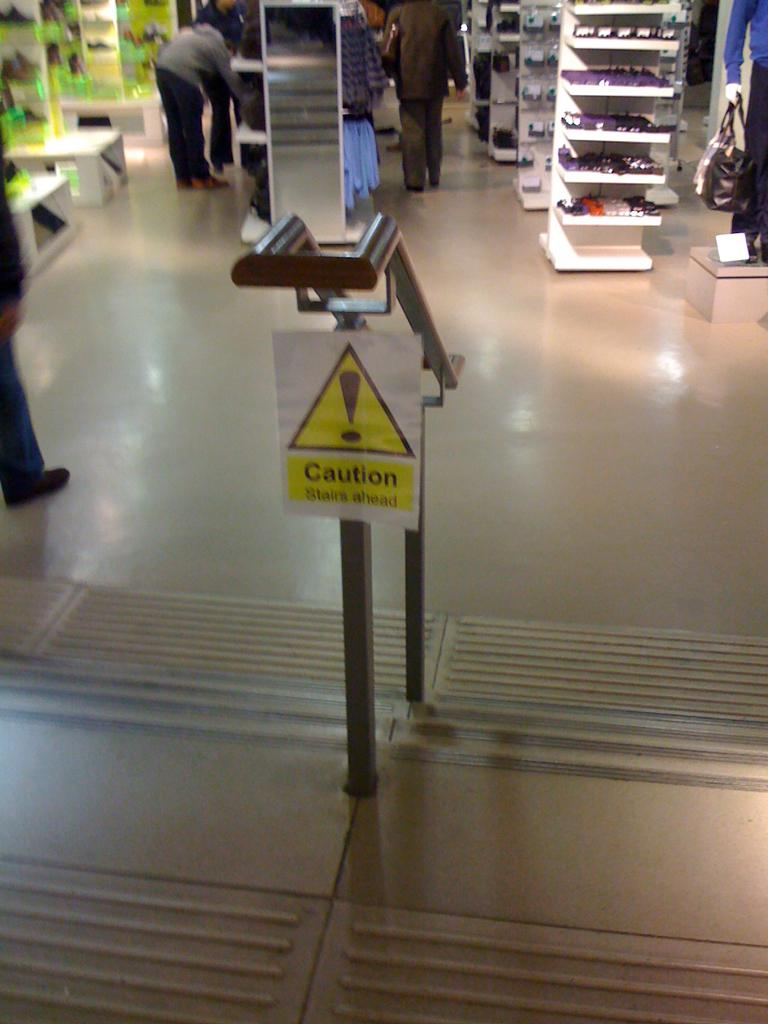What is located in the center of the image? There are stairs and a sign board in the center of the image. What can be seen in the background of the image? There are objects arranged in racks and a mirror in the background of the image. Are there any people visible in the image? Yes, there are persons in the background of the image. How many sisters are present in the image? There is no mention of sisters in the image, so we cannot determine their presence or number. What type of kitten can be seen playing with the objects in the racks? There is no kitten present in the image; only objects arranged in racks are visible in the background. 